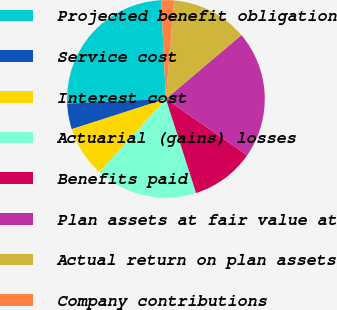<chart> <loc_0><loc_0><loc_500><loc_500><pie_chart><fcel>Projected benefit obligation<fcel>Service cost<fcel>Interest cost<fcel>Actuarial (gains) losses<fcel>Benefits paid<fcel>Plan assets at fair value at<fcel>Actual return on plan assets<fcel>Company contributions<nl><fcel>24.98%<fcel>4.18%<fcel>8.34%<fcel>16.66%<fcel>10.42%<fcel>20.82%<fcel>12.5%<fcel>2.1%<nl></chart> 